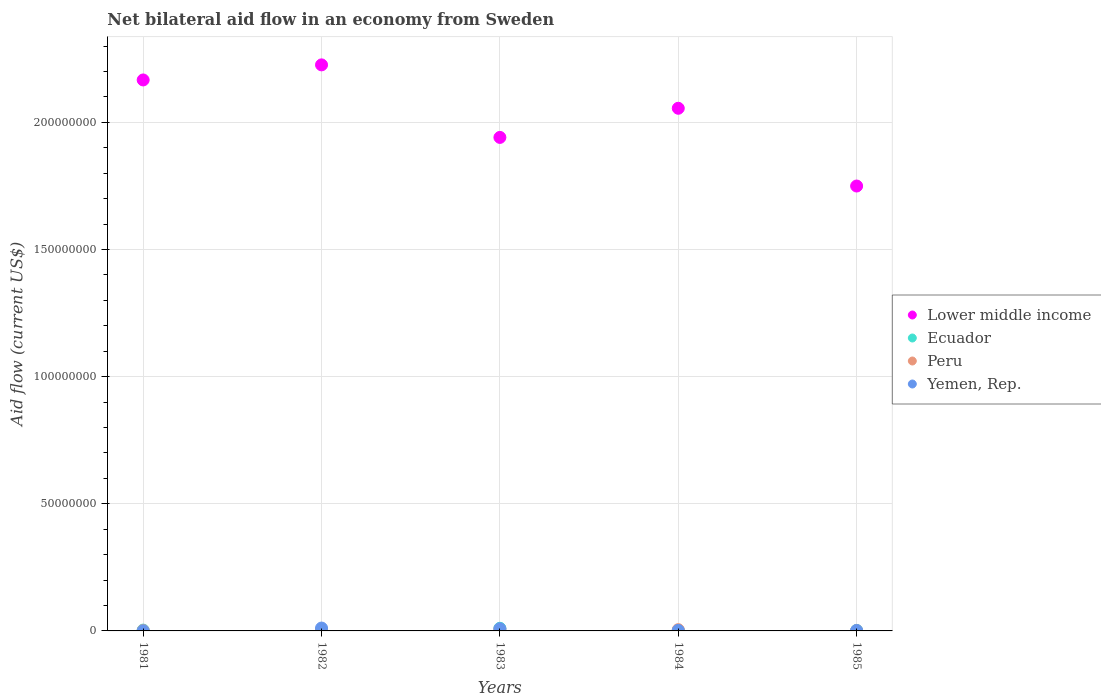How many different coloured dotlines are there?
Offer a terse response. 4. Is the number of dotlines equal to the number of legend labels?
Ensure brevity in your answer.  Yes. What is the net bilateral aid flow in Yemen, Rep. in 1982?
Offer a terse response. 1.13e+06. Across all years, what is the maximum net bilateral aid flow in Peru?
Provide a succinct answer. 6.10e+05. What is the total net bilateral aid flow in Yemen, Rep. in the graph?
Give a very brief answer. 2.38e+06. What is the difference between the net bilateral aid flow in Ecuador in 1983 and that in 1985?
Make the answer very short. 8.30e+05. What is the average net bilateral aid flow in Peru per year?
Ensure brevity in your answer.  3.08e+05. In the year 1981, what is the difference between the net bilateral aid flow in Lower middle income and net bilateral aid flow in Ecuador?
Offer a terse response. 2.16e+08. What is the ratio of the net bilateral aid flow in Lower middle income in 1982 to that in 1984?
Your answer should be compact. 1.08. Is the net bilateral aid flow in Yemen, Rep. in 1982 less than that in 1983?
Your answer should be compact. No. Is the difference between the net bilateral aid flow in Lower middle income in 1981 and 1984 greater than the difference between the net bilateral aid flow in Ecuador in 1981 and 1984?
Your answer should be compact. Yes. What is the difference between the highest and the second highest net bilateral aid flow in Ecuador?
Offer a very short reply. 6.00e+05. What is the difference between the highest and the lowest net bilateral aid flow in Peru?
Keep it short and to the point. 5.00e+05. In how many years, is the net bilateral aid flow in Yemen, Rep. greater than the average net bilateral aid flow in Yemen, Rep. taken over all years?
Provide a succinct answer. 2. Is the sum of the net bilateral aid flow in Ecuador in 1983 and 1985 greater than the maximum net bilateral aid flow in Lower middle income across all years?
Keep it short and to the point. No. Is it the case that in every year, the sum of the net bilateral aid flow in Yemen, Rep. and net bilateral aid flow in Peru  is greater than the sum of net bilateral aid flow in Lower middle income and net bilateral aid flow in Ecuador?
Your answer should be very brief. No. Is the net bilateral aid flow in Yemen, Rep. strictly less than the net bilateral aid flow in Lower middle income over the years?
Your response must be concise. Yes. How many years are there in the graph?
Provide a succinct answer. 5. Are the values on the major ticks of Y-axis written in scientific E-notation?
Give a very brief answer. No. Where does the legend appear in the graph?
Offer a terse response. Center right. How are the legend labels stacked?
Keep it short and to the point. Vertical. What is the title of the graph?
Offer a terse response. Net bilateral aid flow in an economy from Sweden. Does "Myanmar" appear as one of the legend labels in the graph?
Your response must be concise. No. What is the label or title of the Y-axis?
Your answer should be compact. Aid flow (current US$). What is the Aid flow (current US$) in Lower middle income in 1981?
Your response must be concise. 2.17e+08. What is the Aid flow (current US$) in Ecuador in 1981?
Give a very brief answer. 3.30e+05. What is the Aid flow (current US$) of Peru in 1981?
Your answer should be compact. 1.20e+05. What is the Aid flow (current US$) of Yemen, Rep. in 1981?
Ensure brevity in your answer.  3.00e+04. What is the Aid flow (current US$) in Lower middle income in 1982?
Provide a succinct answer. 2.23e+08. What is the Aid flow (current US$) of Peru in 1982?
Offer a terse response. 2.00e+05. What is the Aid flow (current US$) in Yemen, Rep. in 1982?
Provide a succinct answer. 1.13e+06. What is the Aid flow (current US$) in Lower middle income in 1983?
Offer a very short reply. 1.94e+08. What is the Aid flow (current US$) of Ecuador in 1983?
Your answer should be very brief. 1.04e+06. What is the Aid flow (current US$) in Peru in 1983?
Your answer should be compact. 6.10e+05. What is the Aid flow (current US$) in Yemen, Rep. in 1983?
Make the answer very short. 8.50e+05. What is the Aid flow (current US$) of Lower middle income in 1984?
Ensure brevity in your answer.  2.06e+08. What is the Aid flow (current US$) of Ecuador in 1984?
Offer a very short reply. 1.60e+05. What is the Aid flow (current US$) in Peru in 1984?
Your answer should be compact. 5.00e+05. What is the Aid flow (current US$) in Lower middle income in 1985?
Provide a short and direct response. 1.75e+08. What is the Aid flow (current US$) in Yemen, Rep. in 1985?
Ensure brevity in your answer.  1.60e+05. Across all years, what is the maximum Aid flow (current US$) of Lower middle income?
Provide a succinct answer. 2.23e+08. Across all years, what is the maximum Aid flow (current US$) of Ecuador?
Offer a very short reply. 1.04e+06. Across all years, what is the maximum Aid flow (current US$) of Peru?
Your response must be concise. 6.10e+05. Across all years, what is the maximum Aid flow (current US$) in Yemen, Rep.?
Give a very brief answer. 1.13e+06. Across all years, what is the minimum Aid flow (current US$) of Lower middle income?
Your answer should be compact. 1.75e+08. What is the total Aid flow (current US$) in Lower middle income in the graph?
Offer a terse response. 1.01e+09. What is the total Aid flow (current US$) of Ecuador in the graph?
Provide a succinct answer. 2.18e+06. What is the total Aid flow (current US$) in Peru in the graph?
Give a very brief answer. 1.54e+06. What is the total Aid flow (current US$) in Yemen, Rep. in the graph?
Offer a terse response. 2.38e+06. What is the difference between the Aid flow (current US$) of Lower middle income in 1981 and that in 1982?
Your response must be concise. -5.93e+06. What is the difference between the Aid flow (current US$) in Peru in 1981 and that in 1982?
Your answer should be compact. -8.00e+04. What is the difference between the Aid flow (current US$) in Yemen, Rep. in 1981 and that in 1982?
Your answer should be compact. -1.10e+06. What is the difference between the Aid flow (current US$) of Lower middle income in 1981 and that in 1983?
Give a very brief answer. 2.26e+07. What is the difference between the Aid flow (current US$) of Ecuador in 1981 and that in 1983?
Offer a very short reply. -7.10e+05. What is the difference between the Aid flow (current US$) of Peru in 1981 and that in 1983?
Ensure brevity in your answer.  -4.90e+05. What is the difference between the Aid flow (current US$) of Yemen, Rep. in 1981 and that in 1983?
Offer a terse response. -8.20e+05. What is the difference between the Aid flow (current US$) in Lower middle income in 1981 and that in 1984?
Keep it short and to the point. 1.11e+07. What is the difference between the Aid flow (current US$) of Peru in 1981 and that in 1984?
Your answer should be compact. -3.80e+05. What is the difference between the Aid flow (current US$) in Lower middle income in 1981 and that in 1985?
Your answer should be compact. 4.17e+07. What is the difference between the Aid flow (current US$) of Ecuador in 1981 and that in 1985?
Your response must be concise. 1.20e+05. What is the difference between the Aid flow (current US$) of Peru in 1981 and that in 1985?
Give a very brief answer. 10000. What is the difference between the Aid flow (current US$) of Yemen, Rep. in 1981 and that in 1985?
Give a very brief answer. -1.30e+05. What is the difference between the Aid flow (current US$) of Lower middle income in 1982 and that in 1983?
Give a very brief answer. 2.85e+07. What is the difference between the Aid flow (current US$) in Ecuador in 1982 and that in 1983?
Provide a short and direct response. -6.00e+05. What is the difference between the Aid flow (current US$) in Peru in 1982 and that in 1983?
Provide a short and direct response. -4.10e+05. What is the difference between the Aid flow (current US$) of Lower middle income in 1982 and that in 1984?
Provide a short and direct response. 1.71e+07. What is the difference between the Aid flow (current US$) in Ecuador in 1982 and that in 1984?
Keep it short and to the point. 2.80e+05. What is the difference between the Aid flow (current US$) in Peru in 1982 and that in 1984?
Your answer should be compact. -3.00e+05. What is the difference between the Aid flow (current US$) of Yemen, Rep. in 1982 and that in 1984?
Ensure brevity in your answer.  9.20e+05. What is the difference between the Aid flow (current US$) of Lower middle income in 1982 and that in 1985?
Your response must be concise. 4.76e+07. What is the difference between the Aid flow (current US$) in Ecuador in 1982 and that in 1985?
Give a very brief answer. 2.30e+05. What is the difference between the Aid flow (current US$) of Peru in 1982 and that in 1985?
Your answer should be compact. 9.00e+04. What is the difference between the Aid flow (current US$) in Yemen, Rep. in 1982 and that in 1985?
Your answer should be very brief. 9.70e+05. What is the difference between the Aid flow (current US$) of Lower middle income in 1983 and that in 1984?
Offer a terse response. -1.15e+07. What is the difference between the Aid flow (current US$) of Ecuador in 1983 and that in 1984?
Your response must be concise. 8.80e+05. What is the difference between the Aid flow (current US$) of Yemen, Rep. in 1983 and that in 1984?
Your answer should be very brief. 6.40e+05. What is the difference between the Aid flow (current US$) in Lower middle income in 1983 and that in 1985?
Provide a succinct answer. 1.91e+07. What is the difference between the Aid flow (current US$) of Ecuador in 1983 and that in 1985?
Make the answer very short. 8.30e+05. What is the difference between the Aid flow (current US$) of Peru in 1983 and that in 1985?
Ensure brevity in your answer.  5.00e+05. What is the difference between the Aid flow (current US$) of Yemen, Rep. in 1983 and that in 1985?
Make the answer very short. 6.90e+05. What is the difference between the Aid flow (current US$) in Lower middle income in 1984 and that in 1985?
Provide a short and direct response. 3.06e+07. What is the difference between the Aid flow (current US$) of Yemen, Rep. in 1984 and that in 1985?
Give a very brief answer. 5.00e+04. What is the difference between the Aid flow (current US$) of Lower middle income in 1981 and the Aid flow (current US$) of Ecuador in 1982?
Ensure brevity in your answer.  2.16e+08. What is the difference between the Aid flow (current US$) in Lower middle income in 1981 and the Aid flow (current US$) in Peru in 1982?
Make the answer very short. 2.16e+08. What is the difference between the Aid flow (current US$) of Lower middle income in 1981 and the Aid flow (current US$) of Yemen, Rep. in 1982?
Offer a very short reply. 2.16e+08. What is the difference between the Aid flow (current US$) of Ecuador in 1981 and the Aid flow (current US$) of Peru in 1982?
Your answer should be compact. 1.30e+05. What is the difference between the Aid flow (current US$) of Ecuador in 1981 and the Aid flow (current US$) of Yemen, Rep. in 1982?
Provide a short and direct response. -8.00e+05. What is the difference between the Aid flow (current US$) of Peru in 1981 and the Aid flow (current US$) of Yemen, Rep. in 1982?
Your response must be concise. -1.01e+06. What is the difference between the Aid flow (current US$) of Lower middle income in 1981 and the Aid flow (current US$) of Ecuador in 1983?
Offer a very short reply. 2.16e+08. What is the difference between the Aid flow (current US$) in Lower middle income in 1981 and the Aid flow (current US$) in Peru in 1983?
Provide a succinct answer. 2.16e+08. What is the difference between the Aid flow (current US$) of Lower middle income in 1981 and the Aid flow (current US$) of Yemen, Rep. in 1983?
Ensure brevity in your answer.  2.16e+08. What is the difference between the Aid flow (current US$) in Ecuador in 1981 and the Aid flow (current US$) in Peru in 1983?
Make the answer very short. -2.80e+05. What is the difference between the Aid flow (current US$) of Ecuador in 1981 and the Aid flow (current US$) of Yemen, Rep. in 1983?
Keep it short and to the point. -5.20e+05. What is the difference between the Aid flow (current US$) in Peru in 1981 and the Aid flow (current US$) in Yemen, Rep. in 1983?
Your answer should be very brief. -7.30e+05. What is the difference between the Aid flow (current US$) of Lower middle income in 1981 and the Aid flow (current US$) of Ecuador in 1984?
Give a very brief answer. 2.17e+08. What is the difference between the Aid flow (current US$) in Lower middle income in 1981 and the Aid flow (current US$) in Peru in 1984?
Offer a terse response. 2.16e+08. What is the difference between the Aid flow (current US$) of Lower middle income in 1981 and the Aid flow (current US$) of Yemen, Rep. in 1984?
Offer a very short reply. 2.16e+08. What is the difference between the Aid flow (current US$) in Ecuador in 1981 and the Aid flow (current US$) in Peru in 1984?
Offer a terse response. -1.70e+05. What is the difference between the Aid flow (current US$) of Peru in 1981 and the Aid flow (current US$) of Yemen, Rep. in 1984?
Offer a very short reply. -9.00e+04. What is the difference between the Aid flow (current US$) of Lower middle income in 1981 and the Aid flow (current US$) of Ecuador in 1985?
Keep it short and to the point. 2.16e+08. What is the difference between the Aid flow (current US$) of Lower middle income in 1981 and the Aid flow (current US$) of Peru in 1985?
Keep it short and to the point. 2.17e+08. What is the difference between the Aid flow (current US$) in Lower middle income in 1981 and the Aid flow (current US$) in Yemen, Rep. in 1985?
Provide a short and direct response. 2.17e+08. What is the difference between the Aid flow (current US$) in Ecuador in 1981 and the Aid flow (current US$) in Peru in 1985?
Give a very brief answer. 2.20e+05. What is the difference between the Aid flow (current US$) of Ecuador in 1981 and the Aid flow (current US$) of Yemen, Rep. in 1985?
Provide a succinct answer. 1.70e+05. What is the difference between the Aid flow (current US$) of Lower middle income in 1982 and the Aid flow (current US$) of Ecuador in 1983?
Offer a terse response. 2.22e+08. What is the difference between the Aid flow (current US$) in Lower middle income in 1982 and the Aid flow (current US$) in Peru in 1983?
Provide a succinct answer. 2.22e+08. What is the difference between the Aid flow (current US$) in Lower middle income in 1982 and the Aid flow (current US$) in Yemen, Rep. in 1983?
Your response must be concise. 2.22e+08. What is the difference between the Aid flow (current US$) of Ecuador in 1982 and the Aid flow (current US$) of Peru in 1983?
Ensure brevity in your answer.  -1.70e+05. What is the difference between the Aid flow (current US$) of Ecuador in 1982 and the Aid flow (current US$) of Yemen, Rep. in 1983?
Your answer should be very brief. -4.10e+05. What is the difference between the Aid flow (current US$) of Peru in 1982 and the Aid flow (current US$) of Yemen, Rep. in 1983?
Your response must be concise. -6.50e+05. What is the difference between the Aid flow (current US$) in Lower middle income in 1982 and the Aid flow (current US$) in Ecuador in 1984?
Offer a very short reply. 2.22e+08. What is the difference between the Aid flow (current US$) in Lower middle income in 1982 and the Aid flow (current US$) in Peru in 1984?
Your answer should be very brief. 2.22e+08. What is the difference between the Aid flow (current US$) of Lower middle income in 1982 and the Aid flow (current US$) of Yemen, Rep. in 1984?
Provide a short and direct response. 2.22e+08. What is the difference between the Aid flow (current US$) in Ecuador in 1982 and the Aid flow (current US$) in Peru in 1984?
Give a very brief answer. -6.00e+04. What is the difference between the Aid flow (current US$) in Ecuador in 1982 and the Aid flow (current US$) in Yemen, Rep. in 1984?
Your answer should be compact. 2.30e+05. What is the difference between the Aid flow (current US$) of Peru in 1982 and the Aid flow (current US$) of Yemen, Rep. in 1984?
Ensure brevity in your answer.  -10000. What is the difference between the Aid flow (current US$) of Lower middle income in 1982 and the Aid flow (current US$) of Ecuador in 1985?
Offer a very short reply. 2.22e+08. What is the difference between the Aid flow (current US$) in Lower middle income in 1982 and the Aid flow (current US$) in Peru in 1985?
Your answer should be very brief. 2.23e+08. What is the difference between the Aid flow (current US$) in Lower middle income in 1982 and the Aid flow (current US$) in Yemen, Rep. in 1985?
Your response must be concise. 2.22e+08. What is the difference between the Aid flow (current US$) in Ecuador in 1982 and the Aid flow (current US$) in Peru in 1985?
Give a very brief answer. 3.30e+05. What is the difference between the Aid flow (current US$) in Lower middle income in 1983 and the Aid flow (current US$) in Ecuador in 1984?
Your answer should be very brief. 1.94e+08. What is the difference between the Aid flow (current US$) in Lower middle income in 1983 and the Aid flow (current US$) in Peru in 1984?
Provide a short and direct response. 1.94e+08. What is the difference between the Aid flow (current US$) of Lower middle income in 1983 and the Aid flow (current US$) of Yemen, Rep. in 1984?
Provide a short and direct response. 1.94e+08. What is the difference between the Aid flow (current US$) in Ecuador in 1983 and the Aid flow (current US$) in Peru in 1984?
Provide a succinct answer. 5.40e+05. What is the difference between the Aid flow (current US$) in Ecuador in 1983 and the Aid flow (current US$) in Yemen, Rep. in 1984?
Provide a succinct answer. 8.30e+05. What is the difference between the Aid flow (current US$) of Peru in 1983 and the Aid flow (current US$) of Yemen, Rep. in 1984?
Ensure brevity in your answer.  4.00e+05. What is the difference between the Aid flow (current US$) of Lower middle income in 1983 and the Aid flow (current US$) of Ecuador in 1985?
Your answer should be compact. 1.94e+08. What is the difference between the Aid flow (current US$) of Lower middle income in 1983 and the Aid flow (current US$) of Peru in 1985?
Provide a short and direct response. 1.94e+08. What is the difference between the Aid flow (current US$) in Lower middle income in 1983 and the Aid flow (current US$) in Yemen, Rep. in 1985?
Ensure brevity in your answer.  1.94e+08. What is the difference between the Aid flow (current US$) in Ecuador in 1983 and the Aid flow (current US$) in Peru in 1985?
Make the answer very short. 9.30e+05. What is the difference between the Aid flow (current US$) in Ecuador in 1983 and the Aid flow (current US$) in Yemen, Rep. in 1985?
Keep it short and to the point. 8.80e+05. What is the difference between the Aid flow (current US$) in Lower middle income in 1984 and the Aid flow (current US$) in Ecuador in 1985?
Keep it short and to the point. 2.05e+08. What is the difference between the Aid flow (current US$) in Lower middle income in 1984 and the Aid flow (current US$) in Peru in 1985?
Offer a very short reply. 2.05e+08. What is the difference between the Aid flow (current US$) in Lower middle income in 1984 and the Aid flow (current US$) in Yemen, Rep. in 1985?
Keep it short and to the point. 2.05e+08. What is the difference between the Aid flow (current US$) of Ecuador in 1984 and the Aid flow (current US$) of Peru in 1985?
Give a very brief answer. 5.00e+04. What is the difference between the Aid flow (current US$) of Ecuador in 1984 and the Aid flow (current US$) of Yemen, Rep. in 1985?
Your answer should be compact. 0. What is the average Aid flow (current US$) in Lower middle income per year?
Provide a succinct answer. 2.03e+08. What is the average Aid flow (current US$) of Ecuador per year?
Ensure brevity in your answer.  4.36e+05. What is the average Aid flow (current US$) in Peru per year?
Your response must be concise. 3.08e+05. What is the average Aid flow (current US$) of Yemen, Rep. per year?
Give a very brief answer. 4.76e+05. In the year 1981, what is the difference between the Aid flow (current US$) of Lower middle income and Aid flow (current US$) of Ecuador?
Ensure brevity in your answer.  2.16e+08. In the year 1981, what is the difference between the Aid flow (current US$) of Lower middle income and Aid flow (current US$) of Peru?
Give a very brief answer. 2.17e+08. In the year 1981, what is the difference between the Aid flow (current US$) in Lower middle income and Aid flow (current US$) in Yemen, Rep.?
Offer a terse response. 2.17e+08. In the year 1981, what is the difference between the Aid flow (current US$) of Ecuador and Aid flow (current US$) of Peru?
Offer a very short reply. 2.10e+05. In the year 1982, what is the difference between the Aid flow (current US$) of Lower middle income and Aid flow (current US$) of Ecuador?
Your response must be concise. 2.22e+08. In the year 1982, what is the difference between the Aid flow (current US$) of Lower middle income and Aid flow (current US$) of Peru?
Make the answer very short. 2.22e+08. In the year 1982, what is the difference between the Aid flow (current US$) in Lower middle income and Aid flow (current US$) in Yemen, Rep.?
Give a very brief answer. 2.22e+08. In the year 1982, what is the difference between the Aid flow (current US$) of Ecuador and Aid flow (current US$) of Yemen, Rep.?
Give a very brief answer. -6.90e+05. In the year 1982, what is the difference between the Aid flow (current US$) in Peru and Aid flow (current US$) in Yemen, Rep.?
Keep it short and to the point. -9.30e+05. In the year 1983, what is the difference between the Aid flow (current US$) in Lower middle income and Aid flow (current US$) in Ecuador?
Provide a succinct answer. 1.93e+08. In the year 1983, what is the difference between the Aid flow (current US$) in Lower middle income and Aid flow (current US$) in Peru?
Your answer should be compact. 1.93e+08. In the year 1983, what is the difference between the Aid flow (current US$) in Lower middle income and Aid flow (current US$) in Yemen, Rep.?
Your answer should be very brief. 1.93e+08. In the year 1983, what is the difference between the Aid flow (current US$) of Ecuador and Aid flow (current US$) of Peru?
Ensure brevity in your answer.  4.30e+05. In the year 1983, what is the difference between the Aid flow (current US$) of Peru and Aid flow (current US$) of Yemen, Rep.?
Keep it short and to the point. -2.40e+05. In the year 1984, what is the difference between the Aid flow (current US$) of Lower middle income and Aid flow (current US$) of Ecuador?
Keep it short and to the point. 2.05e+08. In the year 1984, what is the difference between the Aid flow (current US$) of Lower middle income and Aid flow (current US$) of Peru?
Provide a succinct answer. 2.05e+08. In the year 1984, what is the difference between the Aid flow (current US$) of Lower middle income and Aid flow (current US$) of Yemen, Rep.?
Provide a short and direct response. 2.05e+08. In the year 1984, what is the difference between the Aid flow (current US$) in Ecuador and Aid flow (current US$) in Peru?
Keep it short and to the point. -3.40e+05. In the year 1985, what is the difference between the Aid flow (current US$) of Lower middle income and Aid flow (current US$) of Ecuador?
Your response must be concise. 1.75e+08. In the year 1985, what is the difference between the Aid flow (current US$) of Lower middle income and Aid flow (current US$) of Peru?
Offer a very short reply. 1.75e+08. In the year 1985, what is the difference between the Aid flow (current US$) of Lower middle income and Aid flow (current US$) of Yemen, Rep.?
Provide a short and direct response. 1.75e+08. In the year 1985, what is the difference between the Aid flow (current US$) in Ecuador and Aid flow (current US$) in Peru?
Your answer should be compact. 1.00e+05. In the year 1985, what is the difference between the Aid flow (current US$) of Peru and Aid flow (current US$) of Yemen, Rep.?
Make the answer very short. -5.00e+04. What is the ratio of the Aid flow (current US$) of Lower middle income in 1981 to that in 1982?
Provide a short and direct response. 0.97. What is the ratio of the Aid flow (current US$) in Yemen, Rep. in 1981 to that in 1982?
Make the answer very short. 0.03. What is the ratio of the Aid flow (current US$) in Lower middle income in 1981 to that in 1983?
Provide a short and direct response. 1.12. What is the ratio of the Aid flow (current US$) in Ecuador in 1981 to that in 1983?
Your response must be concise. 0.32. What is the ratio of the Aid flow (current US$) of Peru in 1981 to that in 1983?
Ensure brevity in your answer.  0.2. What is the ratio of the Aid flow (current US$) of Yemen, Rep. in 1981 to that in 1983?
Ensure brevity in your answer.  0.04. What is the ratio of the Aid flow (current US$) in Lower middle income in 1981 to that in 1984?
Provide a short and direct response. 1.05. What is the ratio of the Aid flow (current US$) of Ecuador in 1981 to that in 1984?
Your answer should be compact. 2.06. What is the ratio of the Aid flow (current US$) of Peru in 1981 to that in 1984?
Ensure brevity in your answer.  0.24. What is the ratio of the Aid flow (current US$) of Yemen, Rep. in 1981 to that in 1984?
Provide a succinct answer. 0.14. What is the ratio of the Aid flow (current US$) in Lower middle income in 1981 to that in 1985?
Offer a terse response. 1.24. What is the ratio of the Aid flow (current US$) in Ecuador in 1981 to that in 1985?
Offer a terse response. 1.57. What is the ratio of the Aid flow (current US$) of Yemen, Rep. in 1981 to that in 1985?
Provide a short and direct response. 0.19. What is the ratio of the Aid flow (current US$) in Lower middle income in 1982 to that in 1983?
Provide a short and direct response. 1.15. What is the ratio of the Aid flow (current US$) of Ecuador in 1982 to that in 1983?
Your response must be concise. 0.42. What is the ratio of the Aid flow (current US$) in Peru in 1982 to that in 1983?
Give a very brief answer. 0.33. What is the ratio of the Aid flow (current US$) of Yemen, Rep. in 1982 to that in 1983?
Your answer should be compact. 1.33. What is the ratio of the Aid flow (current US$) of Lower middle income in 1982 to that in 1984?
Provide a succinct answer. 1.08. What is the ratio of the Aid flow (current US$) of Ecuador in 1982 to that in 1984?
Your response must be concise. 2.75. What is the ratio of the Aid flow (current US$) in Yemen, Rep. in 1982 to that in 1984?
Offer a very short reply. 5.38. What is the ratio of the Aid flow (current US$) in Lower middle income in 1982 to that in 1985?
Keep it short and to the point. 1.27. What is the ratio of the Aid flow (current US$) of Ecuador in 1982 to that in 1985?
Offer a very short reply. 2.1. What is the ratio of the Aid flow (current US$) of Peru in 1982 to that in 1985?
Provide a succinct answer. 1.82. What is the ratio of the Aid flow (current US$) in Yemen, Rep. in 1982 to that in 1985?
Provide a short and direct response. 7.06. What is the ratio of the Aid flow (current US$) in Lower middle income in 1983 to that in 1984?
Provide a succinct answer. 0.94. What is the ratio of the Aid flow (current US$) of Peru in 1983 to that in 1984?
Ensure brevity in your answer.  1.22. What is the ratio of the Aid flow (current US$) in Yemen, Rep. in 1983 to that in 1984?
Give a very brief answer. 4.05. What is the ratio of the Aid flow (current US$) in Lower middle income in 1983 to that in 1985?
Your answer should be very brief. 1.11. What is the ratio of the Aid flow (current US$) in Ecuador in 1983 to that in 1985?
Offer a very short reply. 4.95. What is the ratio of the Aid flow (current US$) of Peru in 1983 to that in 1985?
Offer a very short reply. 5.55. What is the ratio of the Aid flow (current US$) in Yemen, Rep. in 1983 to that in 1985?
Your answer should be compact. 5.31. What is the ratio of the Aid flow (current US$) of Lower middle income in 1984 to that in 1985?
Your answer should be very brief. 1.17. What is the ratio of the Aid flow (current US$) of Ecuador in 1984 to that in 1985?
Your response must be concise. 0.76. What is the ratio of the Aid flow (current US$) of Peru in 1984 to that in 1985?
Ensure brevity in your answer.  4.55. What is the ratio of the Aid flow (current US$) in Yemen, Rep. in 1984 to that in 1985?
Ensure brevity in your answer.  1.31. What is the difference between the highest and the second highest Aid flow (current US$) of Lower middle income?
Your answer should be compact. 5.93e+06. What is the difference between the highest and the second highest Aid flow (current US$) of Ecuador?
Make the answer very short. 6.00e+05. What is the difference between the highest and the second highest Aid flow (current US$) in Peru?
Your answer should be compact. 1.10e+05. What is the difference between the highest and the second highest Aid flow (current US$) in Yemen, Rep.?
Give a very brief answer. 2.80e+05. What is the difference between the highest and the lowest Aid flow (current US$) of Lower middle income?
Make the answer very short. 4.76e+07. What is the difference between the highest and the lowest Aid flow (current US$) of Ecuador?
Your answer should be very brief. 8.80e+05. What is the difference between the highest and the lowest Aid flow (current US$) in Yemen, Rep.?
Offer a terse response. 1.10e+06. 